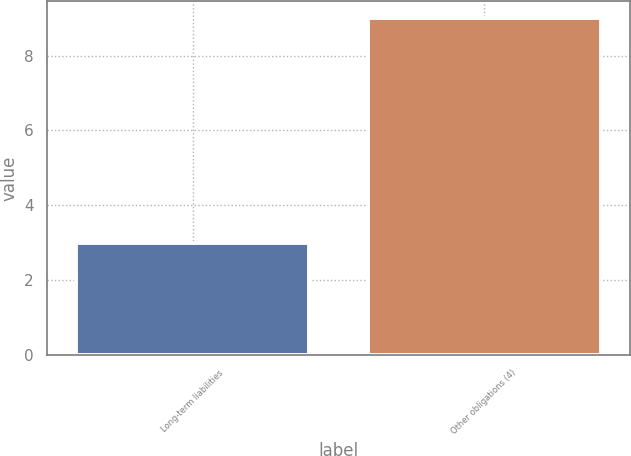Convert chart to OTSL. <chart><loc_0><loc_0><loc_500><loc_500><bar_chart><fcel>Long-term liabilities<fcel>Other obligations (4)<nl><fcel>3<fcel>9<nl></chart> 